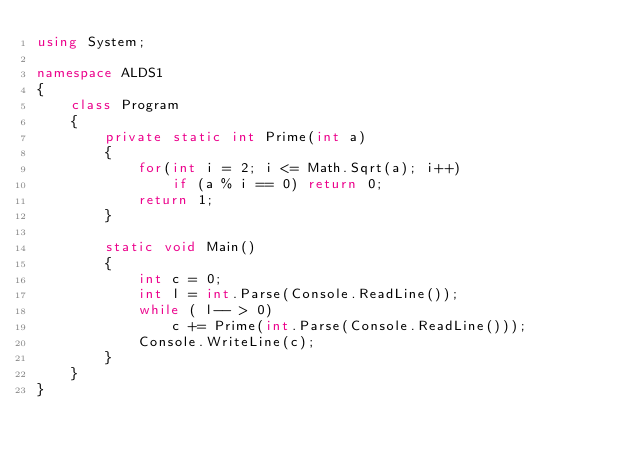<code> <loc_0><loc_0><loc_500><loc_500><_C#_>using System;

namespace ALDS1
{
    class Program
    {
        private static int Prime(int a)
        {
            for(int i = 2; i <= Math.Sqrt(a); i++)
                if (a % i == 0) return 0;
            return 1;
        }

        static void Main()
        {
            int c = 0;
            int l = int.Parse(Console.ReadLine());
            while ( l-- > 0)
                c += Prime(int.Parse(Console.ReadLine()));
            Console.WriteLine(c);
        }
    }
}</code> 